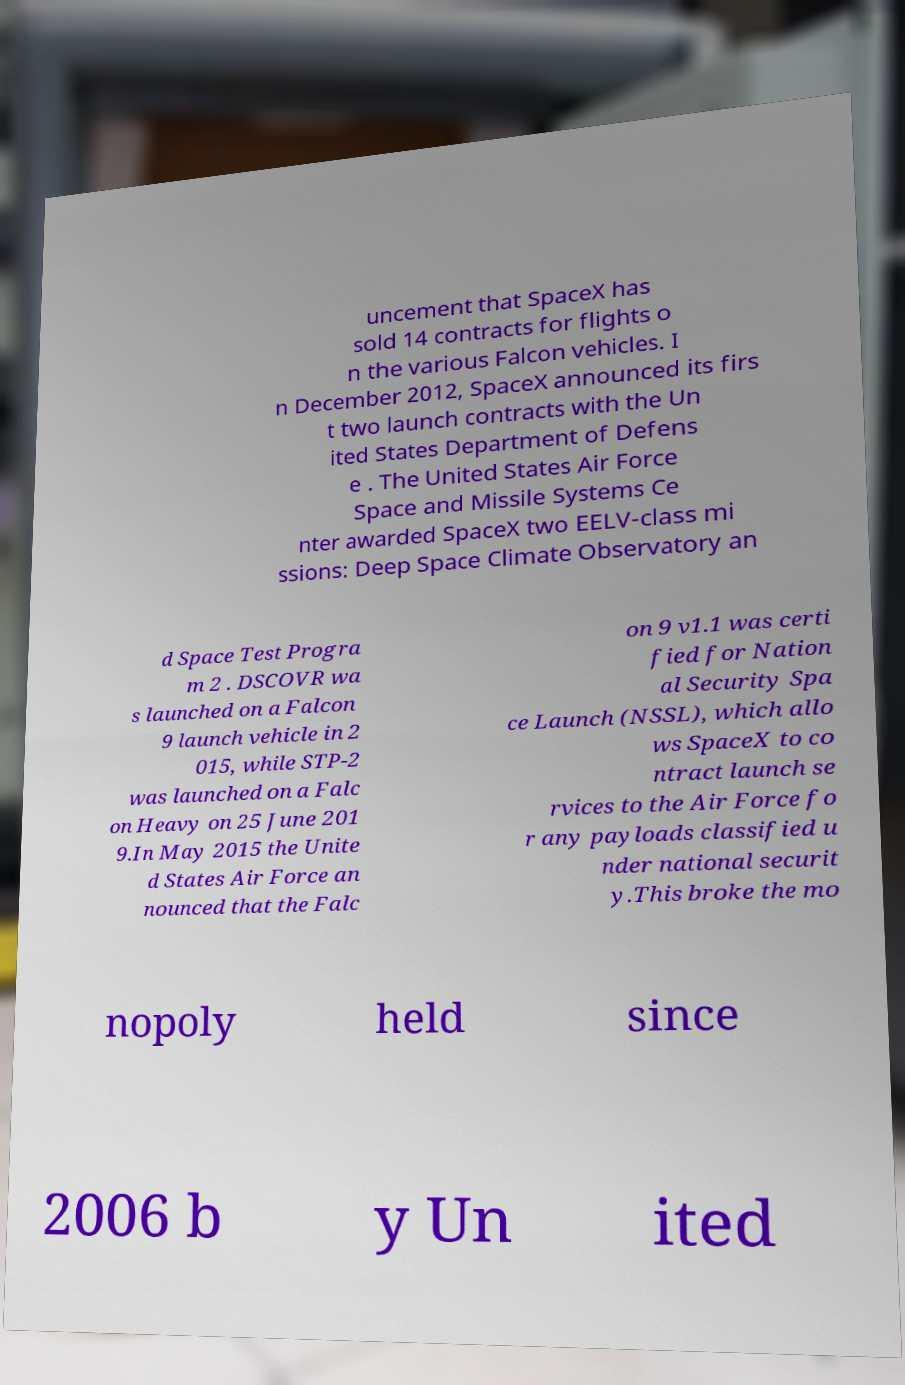Could you assist in decoding the text presented in this image and type it out clearly? uncement that SpaceX has sold 14 contracts for flights o n the various Falcon vehicles. I n December 2012, SpaceX announced its firs t two launch contracts with the Un ited States Department of Defens e . The United States Air Force Space and Missile Systems Ce nter awarded SpaceX two EELV-class mi ssions: Deep Space Climate Observatory an d Space Test Progra m 2 . DSCOVR wa s launched on a Falcon 9 launch vehicle in 2 015, while STP-2 was launched on a Falc on Heavy on 25 June 201 9.In May 2015 the Unite d States Air Force an nounced that the Falc on 9 v1.1 was certi fied for Nation al Security Spa ce Launch (NSSL), which allo ws SpaceX to co ntract launch se rvices to the Air Force fo r any payloads classified u nder national securit y.This broke the mo nopoly held since 2006 b y Un ited 